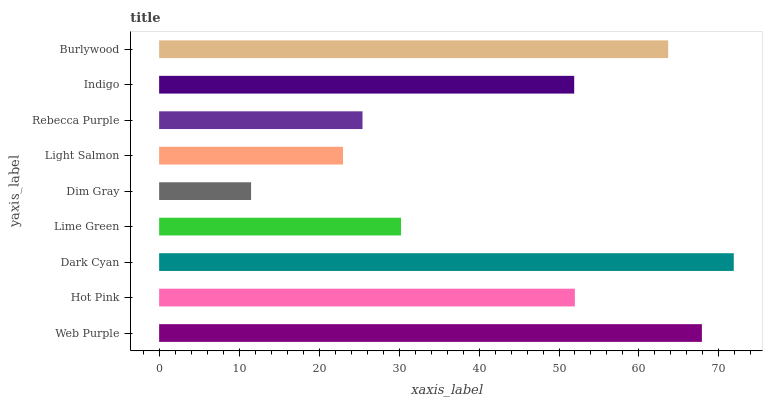Is Dim Gray the minimum?
Answer yes or no. Yes. Is Dark Cyan the maximum?
Answer yes or no. Yes. Is Hot Pink the minimum?
Answer yes or no. No. Is Hot Pink the maximum?
Answer yes or no. No. Is Web Purple greater than Hot Pink?
Answer yes or no. Yes. Is Hot Pink less than Web Purple?
Answer yes or no. Yes. Is Hot Pink greater than Web Purple?
Answer yes or no. No. Is Web Purple less than Hot Pink?
Answer yes or no. No. Is Indigo the high median?
Answer yes or no. Yes. Is Indigo the low median?
Answer yes or no. Yes. Is Lime Green the high median?
Answer yes or no. No. Is Dim Gray the low median?
Answer yes or no. No. 